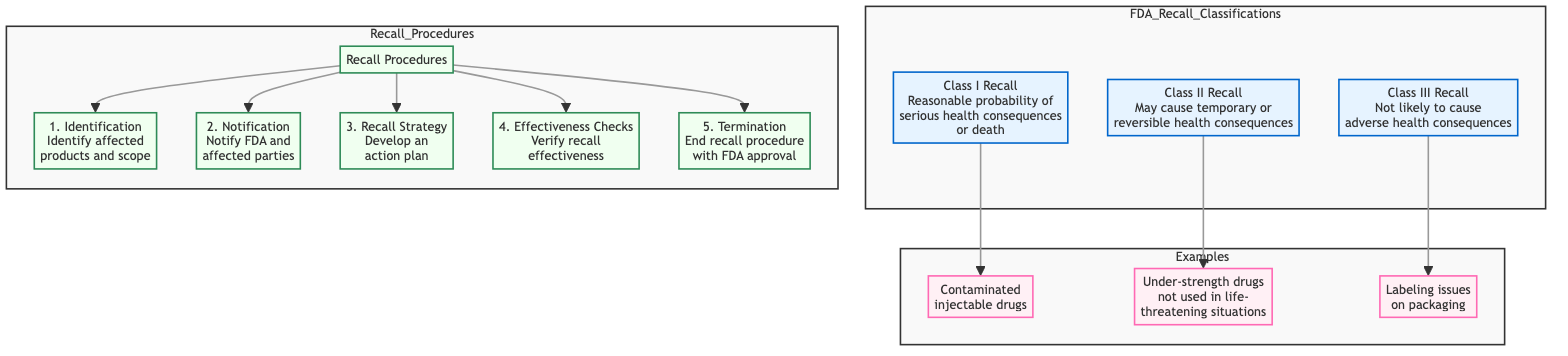What are the three classes of FDA recalls? The diagram lists three classes of FDA recalls: Class I, Class II, and Class III under the FDA Recall Classifications section.
Answer: Class I, Class II, Class III Which class of recall involves contaminated injectable drugs? The diagram indicates that contaminated injectable drugs are an example of a Class I Recall, as shown in the Examples section linked to Class I.
Answer: Class I How many steps are in the recall procedures? The diagram outlines five steps in the Recall Procedures section: Identification, Notification, Recall Strategy, Effectiveness Checks, and Termination. By counting each step, we find that there are a total of five steps.
Answer: 5 What does a Class II Recall indicate? A Class II Recall is indicated by the phrase "May cause temporary or reversible health consequences" in the diagram, describing the potential impact of this class of recalls.
Answer: May cause temporary or reversible health consequences What is the first step in the recall procedures? The diagram states that the first step in the recall procedures is "Identification," which involves identifying affected products and their scope.
Answer: Identification Which class is not likely to cause adverse health consequences? According to the diagram, Class III Recall is defined as "Not likely to cause adverse health consequences," making it clear that this class has the least serious potential impact.
Answer: Class III In which class do under-strength drugs that are not used in life-threatening situations fall? The Examples section of the diagram shows that under-strength drugs not used in life-threatening situations belong to a Class II Recall, as indicated by the linked example.
Answer: Class II What is the last step in the recall procedures? The diagram specifies that the last step in the recall procedures is "Termination," which is stated to end the recall procedure with FDA approval.
Answer: Termination What is included in the class III examples? The diagram indicates that the example for Class III is "Labeling issues on packaging," showing what falls under this specific recall class.
Answer: Labeling issues on packaging 